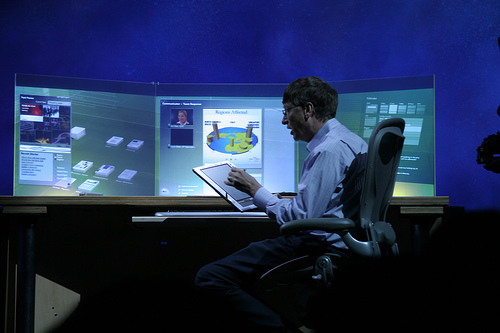<image>
Is the screen behind the man? Yes. From this viewpoint, the screen is positioned behind the man, with the man partially or fully occluding the screen. 